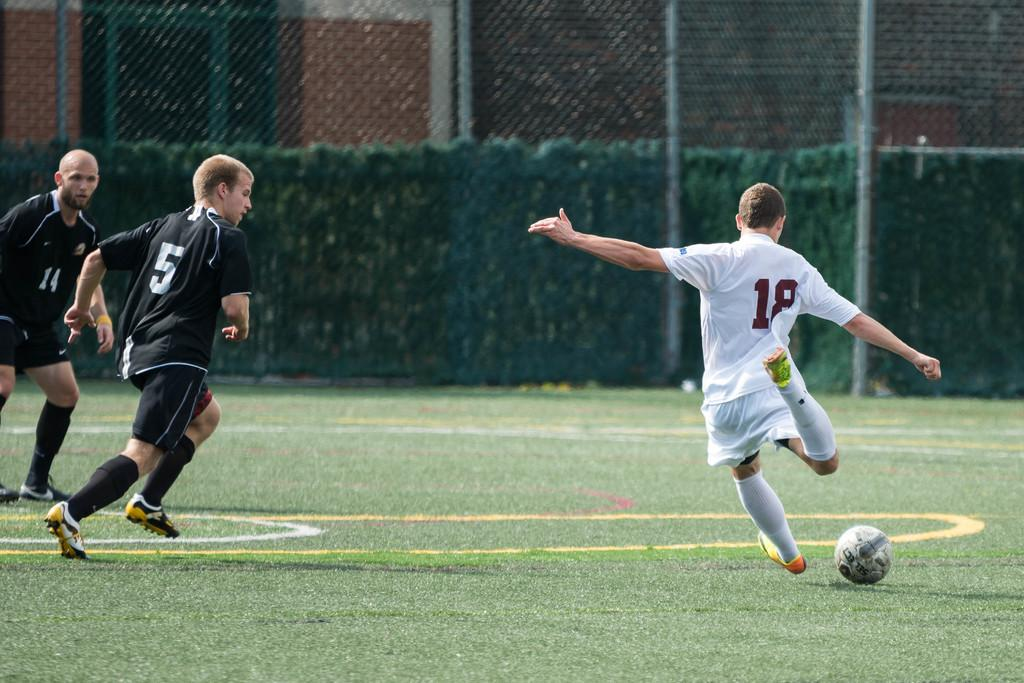How many people are present in the image? There are three persons on the ground in the image. What object can be seen in the image that is typically used in games or sports? There is a ball in the image. What type of vegetation is visible in the background of the image? There are plants in the background of the image. What architectural features can be seen in the background of the image? There is a mesh, rods, and a wall in the background of the image. What type of object made of glass is visible in the background of the image? There is a glass object in the background of the image. What type of activity are the scissors performing in the image? There are no scissors present in the image, so it is not possible to answer that question. 